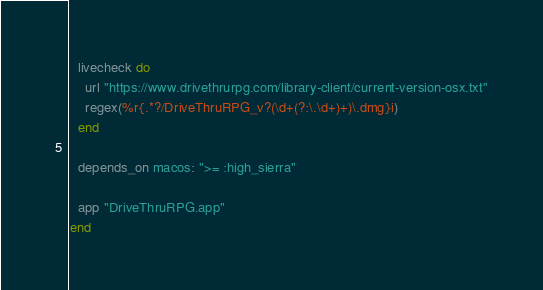Convert code to text. <code><loc_0><loc_0><loc_500><loc_500><_Ruby_>
  livecheck do
    url "https://www.drivethrurpg.com/library-client/current-version-osx.txt"
    regex(%r{.*?/DriveThruRPG_v?(\d+(?:\.\d+)+)\.dmg}i)
  end

  depends_on macos: ">= :high_sierra"

  app "DriveThruRPG.app"
end
</code> 